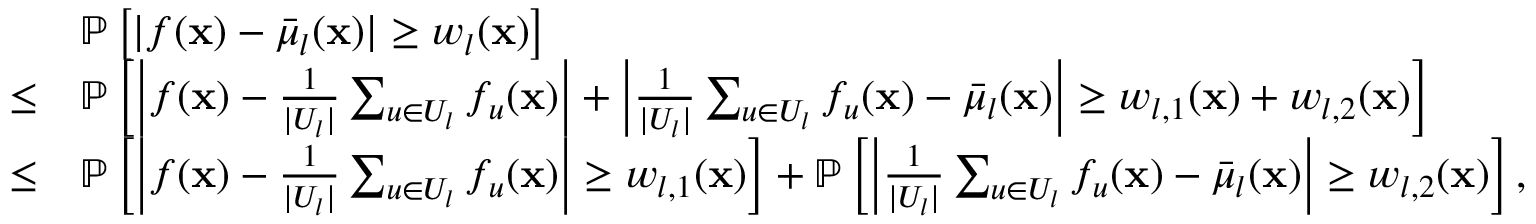Convert formula to latex. <formula><loc_0><loc_0><loc_500><loc_500>\begin{array} { r l } & { \mathbb { P } \left [ | f ( x ) - \bar { \mu } _ { l } ( x ) | \geq w _ { l } ( x ) \right ] } \\ { \leq } & { \mathbb { P } \left [ \left | f ( x ) - \frac { 1 } { | U _ { l } | } \sum _ { u \in U _ { l } } f _ { u } ( x ) \right | + \left | \frac { 1 } { | U _ { l } | } \sum _ { u \in U _ { l } } f _ { u } ( x ) - \bar { \mu } _ { l } ( x ) \right | \geq w _ { l , 1 } ( x ) + w _ { l , 2 } ( x ) \right ] } \\ { \leq } & { \mathbb { P } \left [ \left | f ( x ) - \frac { 1 } { | U _ { l } | } \sum _ { u \in U _ { l } } f _ { u } ( x ) \right | \geq w _ { l , 1 } ( x ) \right ] + \mathbb { P } \left [ \left | \frac { 1 } { | U _ { l } | } \sum _ { u \in U _ { l } } f _ { u } ( x ) - \bar { \mu } _ { l } ( x ) \right | \geq w _ { l , 2 } ( x ) \right ] , } \end{array}</formula> 